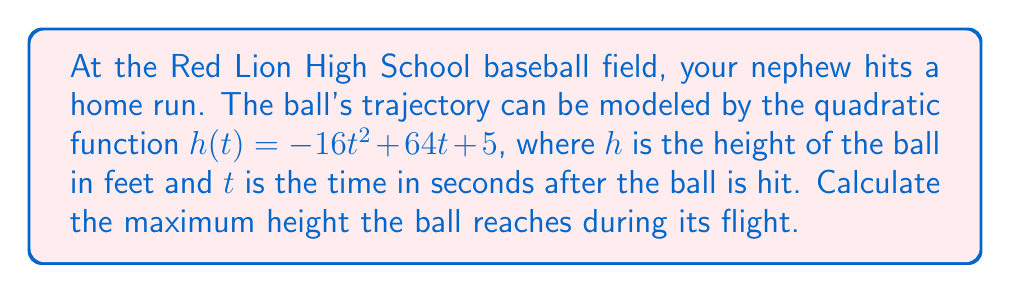Give your solution to this math problem. To find the maximum height of the baseball, we need to find the vertex of the parabola described by the quadratic function. The steps are as follows:

1) The quadratic function is in the form $h(t) = -16t^2 + 64t + 5$, which can be written as $h(t) = a(t^2) + b(t) + c$ where $a = -16$, $b = 64$, and $c = 5$.

2) For a quadratic function in this form, the t-coordinate of the vertex is given by $t = -\frac{b}{2a}$. Let's calculate this:

   $t = -\frac{64}{2(-16)} = -\frac{64}{-32} = 2$ seconds

3) To find the maximum height, we need to calculate $h(2)$:

   $h(2) = -16(2)^2 + 64(2) + 5$
   
   $= -16(4) + 128 + 5$
   
   $= -64 + 128 + 5$
   
   $= 69$ feet

Therefore, the maximum height the ball reaches is 69 feet, occurring 2 seconds after it's hit.
Answer: 69 feet 